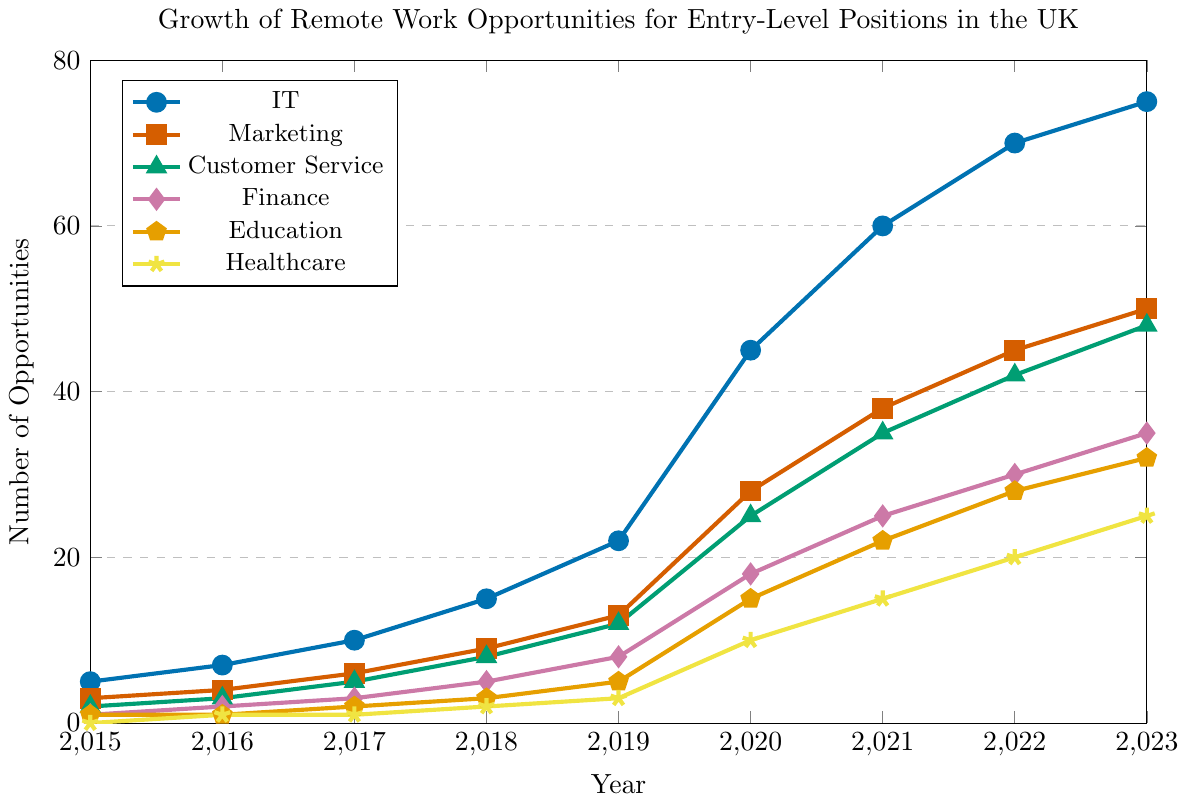Which industry had the highest number of remote work opportunities in 2023? By checking the line chart, the IT industry reached the highest level in 2023 compared to other industries.
Answer: IT How many opportunities were there in Healthcare in 2021 compared to Finance in 2019? In 2021, Healthcare had 15 opportunities, and in 2019, Finance had 8 opportunities.
Answer: Healthcare had 7 more opportunities What is the trend in the number of remote work opportunities in the IT sector from 2015 to 2023? Observing the chart, the IT sector shows a steady increase in remote opportunities from 2015 to 2023, with significant jumps especially in 2020 and 2021.
Answer: Increasing In which year did Marketing exceed 20 opportunities? According to the line for Marketing, it exceeded 20 opportunities in 2020.
Answer: 2020 Compare the growth rate of remote work opportunities between Customer Service and Education from 2019 to 2023. Customer Service grew from 12 to 48, so it increased by 36 opportunities. Education grew from 5 to 32, increasing by 27 opportunities.
Answer: Customer Service had a higher growth rate What were the total opportunities across all industries in 2020? Add the values for each industry in 2020: IT (45) + Marketing (28) + Customer Service (25) + Finance (18) + Education (15) + Healthcare (10) = 141.
Answer: 141 How did the number of opportunities in Education change from 2015 to 2018? In 2015, Education had 1 opportunity and in 2018, it had 3 opportunities.
Answer: Increased by 2 Which industry had the least growth in opportunities from 2018 to 2023? Comparatively, Healthcare grew from 2 in 2018 to 25 in 2023 (23 opportunities), all other industries had more significant growth.
Answer: Healthcare Between which years did Finance see the highest jump in remote work opportunities? Finance saw the biggest increase between 2019 (8) and 2020 (18), a jump of 10 opportunities.
Answer: 2019 to 2020 What is the average number of remote work opportunities in Marketing from 2017 to 2020? Sum of Marketing opportunities from 2017 (6), 2018 (9), 2019 (13), 2020 (28) = 56. Average = 56 / 4 = 14.
Answer: 14 